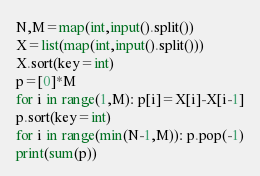Convert code to text. <code><loc_0><loc_0><loc_500><loc_500><_Python_>N,M=map(int,input().split())
X=list(map(int,input().split()))
X.sort(key=int)
p=[0]*M
for i in range(1,M): p[i]=X[i]-X[i-1]
p.sort(key=int)
for i in range(min(N-1,M)): p.pop(-1)
print(sum(p))</code> 